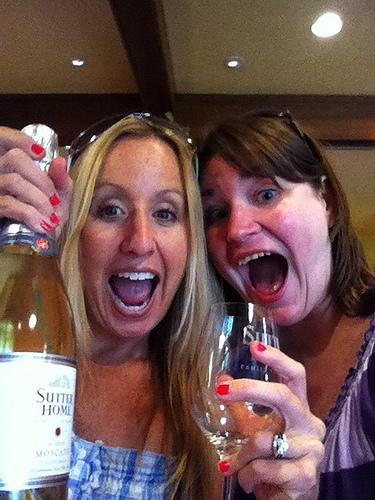Point out the color and location of the wearer of the sunglasses in the image. The wearer of the brown sunglasses on the head is a woman with brown hair. Detail what's unique about the wine bottle in the scene. The wine bottle has a white label with black lettering and a silver foil wrap. Quantify the number of women in the image and share how they are posing. There are two women looking at the camera, both with open mouths. Express the details of the ring worn by one of the women. The brunette woman is wearing a silver and diamond ring on her finger. Identify the type of shirt the blonde woman is wearing and its color. The blonde woman is wearing a blue plaid shirt. 